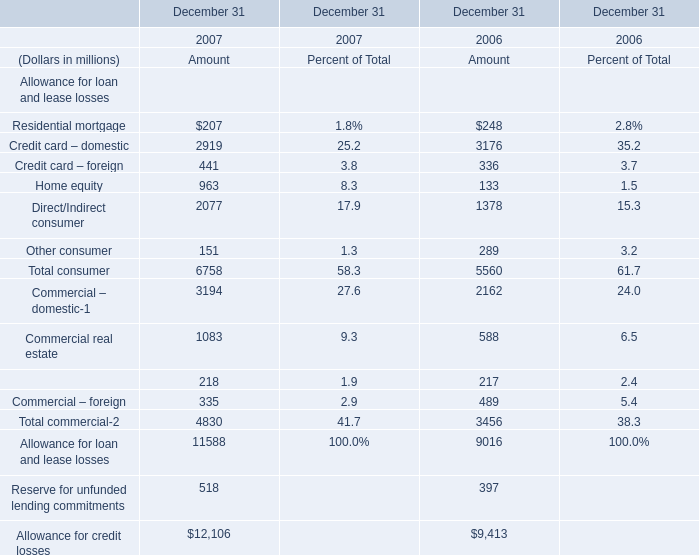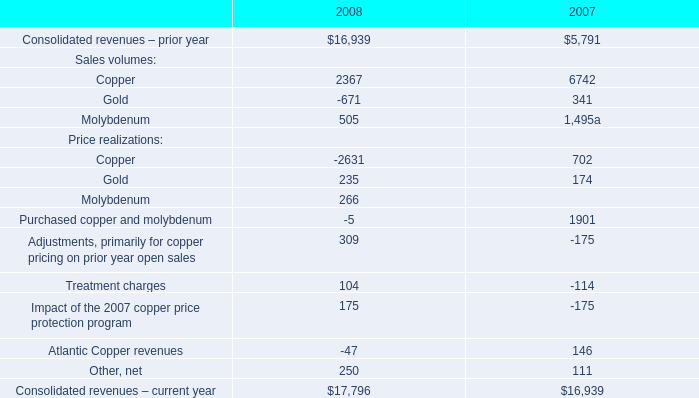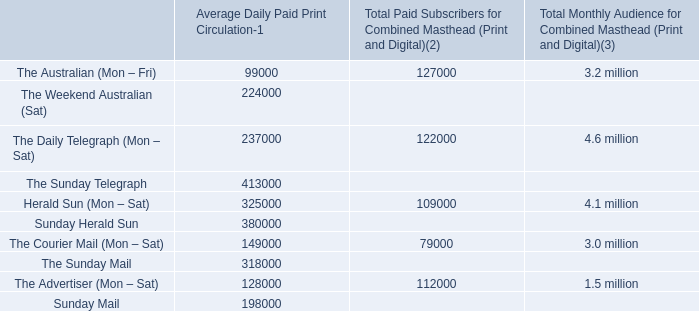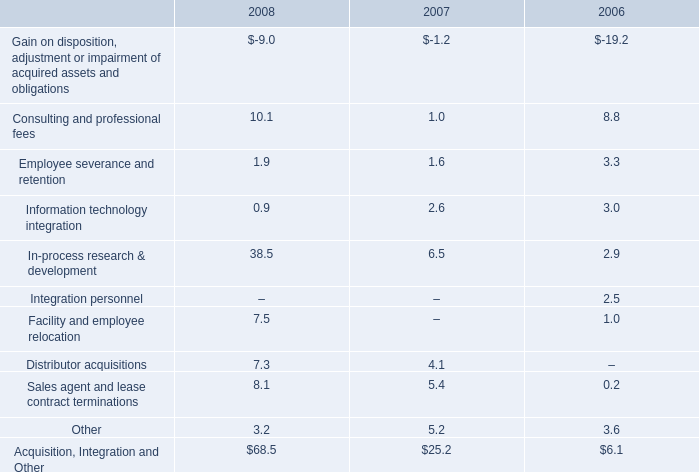what's the total amount of Allowance for credit losses of December 31 2007 Amount, Sunday Herald Sun of Average Daily Paid Print Circulation, and Consolidated revenues – prior year of 2008 ? 
Computations: ((12106.0 + 380000.0) + 16939.0)
Answer: 409045.0. 